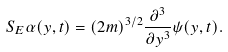Convert formula to latex. <formula><loc_0><loc_0><loc_500><loc_500>S _ { E } \alpha ( y , t ) = ( { 2 m } ) ^ { 3 / 2 } \frac { \partial ^ { 3 } } { \partial y ^ { 3 } } \psi ( y , t ) .</formula> 